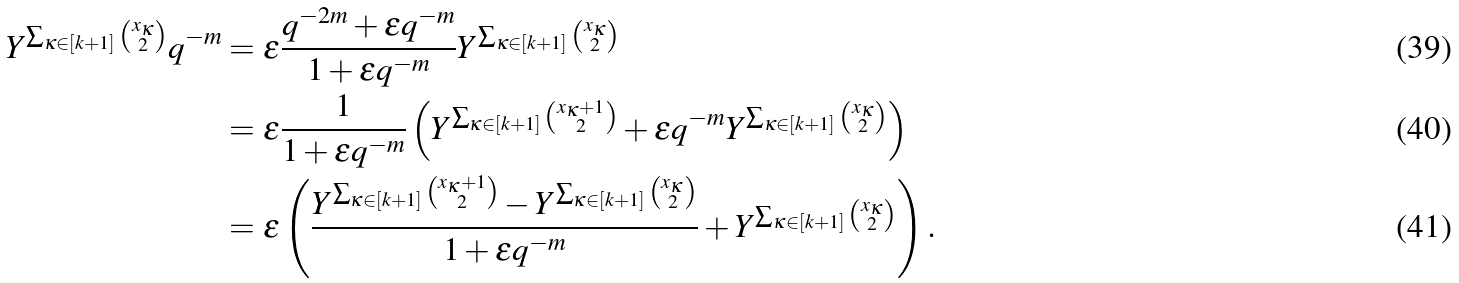Convert formula to latex. <formula><loc_0><loc_0><loc_500><loc_500>Y ^ { \sum _ { \kappa \in [ k + 1 ] } \binom { x _ { \kappa } } { 2 } } q ^ { - m } & = \epsilon \frac { q ^ { - 2 m } + \epsilon q ^ { - m } } { 1 + \epsilon q ^ { - m } } Y ^ { \sum _ { \kappa \in [ k + 1 ] } \binom { x _ { \kappa } } { 2 } } \\ & = \epsilon \frac { 1 } { 1 + \epsilon q ^ { - m } } \left ( Y ^ { \sum _ { \kappa \in [ k + 1 ] } \binom { x _ { \kappa } + 1 } { 2 } } + \epsilon q ^ { - m } Y ^ { \sum _ { \kappa \in [ k + 1 ] } \binom { x _ { \kappa } } { 2 } } \right ) \\ & = \epsilon \left ( \frac { Y ^ { \sum _ { \kappa \in [ k + 1 ] } \binom { x _ { \kappa } + 1 } { 2 } } - Y ^ { \sum _ { \kappa \in [ k + 1 ] } \binom { x _ { \kappa } } { 2 } } } { 1 + \epsilon q ^ { - m } } + Y ^ { \sum _ { \kappa \in [ k + 1 ] } \binom { x _ { \kappa } } { 2 } } \right ) .</formula> 